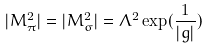<formula> <loc_0><loc_0><loc_500><loc_500>| M _ { \pi } ^ { 2 } | = | M _ { \sigma } ^ { 2 } | = \Lambda ^ { 2 } \exp ( \frac { 1 } { | g | } )</formula> 